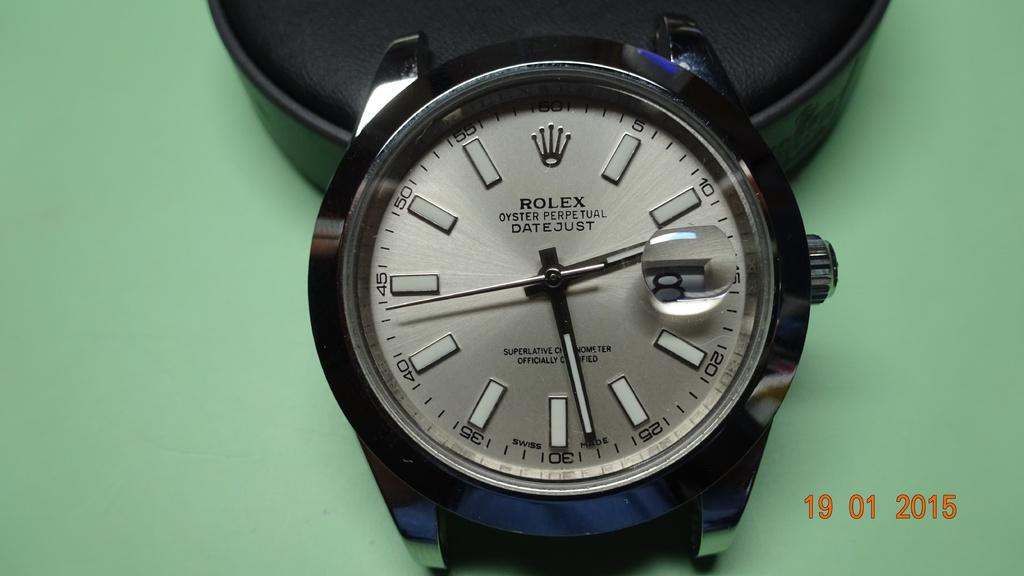<image>
Provide a brief description of the given image. A Rolex watch says it has Oyster Perpetual Datejust. 